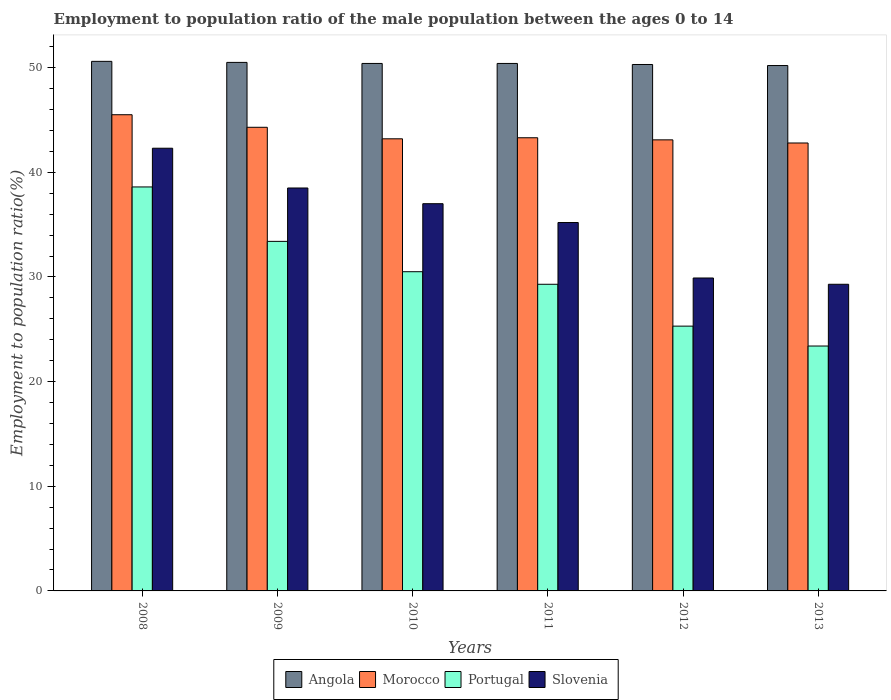How many groups of bars are there?
Ensure brevity in your answer.  6. Are the number of bars per tick equal to the number of legend labels?
Make the answer very short. Yes. How many bars are there on the 2nd tick from the left?
Offer a terse response. 4. What is the label of the 4th group of bars from the left?
Make the answer very short. 2011. What is the employment to population ratio in Angola in 2011?
Offer a terse response. 50.4. Across all years, what is the maximum employment to population ratio in Angola?
Provide a short and direct response. 50.6. Across all years, what is the minimum employment to population ratio in Portugal?
Give a very brief answer. 23.4. In which year was the employment to population ratio in Angola maximum?
Ensure brevity in your answer.  2008. What is the total employment to population ratio in Portugal in the graph?
Your response must be concise. 180.5. What is the difference between the employment to population ratio in Portugal in 2011 and the employment to population ratio in Morocco in 2013?
Your response must be concise. -13.5. What is the average employment to population ratio in Portugal per year?
Your answer should be compact. 30.08. In the year 2009, what is the difference between the employment to population ratio in Angola and employment to population ratio in Portugal?
Offer a terse response. 17.1. In how many years, is the employment to population ratio in Angola greater than 44 %?
Provide a succinct answer. 6. What is the ratio of the employment to population ratio in Portugal in 2009 to that in 2010?
Keep it short and to the point. 1.1. Is the employment to population ratio in Portugal in 2008 less than that in 2013?
Offer a terse response. No. What is the difference between the highest and the second highest employment to population ratio in Angola?
Offer a terse response. 0.1. What is the difference between the highest and the lowest employment to population ratio in Angola?
Keep it short and to the point. 0.4. What does the 4th bar from the left in 2009 represents?
Offer a terse response. Slovenia. What does the 3rd bar from the right in 2013 represents?
Make the answer very short. Morocco. Is it the case that in every year, the sum of the employment to population ratio in Slovenia and employment to population ratio in Morocco is greater than the employment to population ratio in Portugal?
Make the answer very short. Yes. How many bars are there?
Provide a short and direct response. 24. How many years are there in the graph?
Give a very brief answer. 6. What is the difference between two consecutive major ticks on the Y-axis?
Your answer should be very brief. 10. Where does the legend appear in the graph?
Provide a succinct answer. Bottom center. What is the title of the graph?
Your answer should be compact. Employment to population ratio of the male population between the ages 0 to 14. What is the label or title of the Y-axis?
Offer a very short reply. Employment to population ratio(%). What is the Employment to population ratio(%) of Angola in 2008?
Offer a very short reply. 50.6. What is the Employment to population ratio(%) in Morocco in 2008?
Keep it short and to the point. 45.5. What is the Employment to population ratio(%) of Portugal in 2008?
Provide a short and direct response. 38.6. What is the Employment to population ratio(%) in Slovenia in 2008?
Provide a succinct answer. 42.3. What is the Employment to population ratio(%) of Angola in 2009?
Provide a short and direct response. 50.5. What is the Employment to population ratio(%) of Morocco in 2009?
Ensure brevity in your answer.  44.3. What is the Employment to population ratio(%) of Portugal in 2009?
Keep it short and to the point. 33.4. What is the Employment to population ratio(%) of Slovenia in 2009?
Give a very brief answer. 38.5. What is the Employment to population ratio(%) of Angola in 2010?
Offer a terse response. 50.4. What is the Employment to population ratio(%) of Morocco in 2010?
Make the answer very short. 43.2. What is the Employment to population ratio(%) of Portugal in 2010?
Keep it short and to the point. 30.5. What is the Employment to population ratio(%) in Angola in 2011?
Offer a terse response. 50.4. What is the Employment to population ratio(%) of Morocco in 2011?
Give a very brief answer. 43.3. What is the Employment to population ratio(%) in Portugal in 2011?
Offer a very short reply. 29.3. What is the Employment to population ratio(%) in Slovenia in 2011?
Give a very brief answer. 35.2. What is the Employment to population ratio(%) of Angola in 2012?
Provide a short and direct response. 50.3. What is the Employment to population ratio(%) of Morocco in 2012?
Your answer should be very brief. 43.1. What is the Employment to population ratio(%) of Portugal in 2012?
Your answer should be very brief. 25.3. What is the Employment to population ratio(%) of Slovenia in 2012?
Provide a succinct answer. 29.9. What is the Employment to population ratio(%) of Angola in 2013?
Your answer should be compact. 50.2. What is the Employment to population ratio(%) of Morocco in 2013?
Provide a succinct answer. 42.8. What is the Employment to population ratio(%) in Portugal in 2013?
Ensure brevity in your answer.  23.4. What is the Employment to population ratio(%) of Slovenia in 2013?
Keep it short and to the point. 29.3. Across all years, what is the maximum Employment to population ratio(%) of Angola?
Make the answer very short. 50.6. Across all years, what is the maximum Employment to population ratio(%) of Morocco?
Provide a succinct answer. 45.5. Across all years, what is the maximum Employment to population ratio(%) in Portugal?
Provide a short and direct response. 38.6. Across all years, what is the maximum Employment to population ratio(%) of Slovenia?
Your answer should be very brief. 42.3. Across all years, what is the minimum Employment to population ratio(%) in Angola?
Make the answer very short. 50.2. Across all years, what is the minimum Employment to population ratio(%) in Morocco?
Offer a terse response. 42.8. Across all years, what is the minimum Employment to population ratio(%) of Portugal?
Give a very brief answer. 23.4. Across all years, what is the minimum Employment to population ratio(%) in Slovenia?
Ensure brevity in your answer.  29.3. What is the total Employment to population ratio(%) of Angola in the graph?
Your answer should be compact. 302.4. What is the total Employment to population ratio(%) of Morocco in the graph?
Give a very brief answer. 262.2. What is the total Employment to population ratio(%) of Portugal in the graph?
Provide a short and direct response. 180.5. What is the total Employment to population ratio(%) in Slovenia in the graph?
Provide a short and direct response. 212.2. What is the difference between the Employment to population ratio(%) in Morocco in 2008 and that in 2009?
Your answer should be very brief. 1.2. What is the difference between the Employment to population ratio(%) in Slovenia in 2008 and that in 2009?
Your answer should be compact. 3.8. What is the difference between the Employment to population ratio(%) in Slovenia in 2008 and that in 2010?
Make the answer very short. 5.3. What is the difference between the Employment to population ratio(%) in Angola in 2008 and that in 2011?
Your response must be concise. 0.2. What is the difference between the Employment to population ratio(%) in Portugal in 2008 and that in 2011?
Provide a succinct answer. 9.3. What is the difference between the Employment to population ratio(%) of Angola in 2008 and that in 2012?
Ensure brevity in your answer.  0.3. What is the difference between the Employment to population ratio(%) in Portugal in 2008 and that in 2012?
Your answer should be compact. 13.3. What is the difference between the Employment to population ratio(%) in Portugal in 2008 and that in 2013?
Provide a short and direct response. 15.2. What is the difference between the Employment to population ratio(%) of Morocco in 2009 and that in 2010?
Offer a very short reply. 1.1. What is the difference between the Employment to population ratio(%) in Angola in 2009 and that in 2011?
Your answer should be compact. 0.1. What is the difference between the Employment to population ratio(%) in Morocco in 2009 and that in 2011?
Provide a succinct answer. 1. What is the difference between the Employment to population ratio(%) of Portugal in 2009 and that in 2011?
Your response must be concise. 4.1. What is the difference between the Employment to population ratio(%) in Angola in 2009 and that in 2012?
Offer a very short reply. 0.2. What is the difference between the Employment to population ratio(%) of Morocco in 2009 and that in 2012?
Provide a succinct answer. 1.2. What is the difference between the Employment to population ratio(%) of Portugal in 2009 and that in 2012?
Your answer should be very brief. 8.1. What is the difference between the Employment to population ratio(%) of Slovenia in 2009 and that in 2012?
Provide a succinct answer. 8.6. What is the difference between the Employment to population ratio(%) in Portugal in 2010 and that in 2011?
Provide a succinct answer. 1.2. What is the difference between the Employment to population ratio(%) in Angola in 2010 and that in 2013?
Offer a terse response. 0.2. What is the difference between the Employment to population ratio(%) in Portugal in 2010 and that in 2013?
Keep it short and to the point. 7.1. What is the difference between the Employment to population ratio(%) in Slovenia in 2010 and that in 2013?
Offer a very short reply. 7.7. What is the difference between the Employment to population ratio(%) of Angola in 2011 and that in 2012?
Provide a short and direct response. 0.1. What is the difference between the Employment to population ratio(%) of Angola in 2011 and that in 2013?
Offer a very short reply. 0.2. What is the difference between the Employment to population ratio(%) in Slovenia in 2011 and that in 2013?
Your answer should be compact. 5.9. What is the difference between the Employment to population ratio(%) of Angola in 2012 and that in 2013?
Provide a short and direct response. 0.1. What is the difference between the Employment to population ratio(%) in Morocco in 2012 and that in 2013?
Make the answer very short. 0.3. What is the difference between the Employment to population ratio(%) of Slovenia in 2012 and that in 2013?
Offer a terse response. 0.6. What is the difference between the Employment to population ratio(%) in Angola in 2008 and the Employment to population ratio(%) in Morocco in 2009?
Offer a very short reply. 6.3. What is the difference between the Employment to population ratio(%) in Angola in 2008 and the Employment to population ratio(%) in Portugal in 2009?
Make the answer very short. 17.2. What is the difference between the Employment to population ratio(%) of Morocco in 2008 and the Employment to population ratio(%) of Portugal in 2009?
Keep it short and to the point. 12.1. What is the difference between the Employment to population ratio(%) in Morocco in 2008 and the Employment to population ratio(%) in Slovenia in 2009?
Offer a terse response. 7. What is the difference between the Employment to population ratio(%) in Portugal in 2008 and the Employment to population ratio(%) in Slovenia in 2009?
Ensure brevity in your answer.  0.1. What is the difference between the Employment to population ratio(%) in Angola in 2008 and the Employment to population ratio(%) in Morocco in 2010?
Your response must be concise. 7.4. What is the difference between the Employment to population ratio(%) in Angola in 2008 and the Employment to population ratio(%) in Portugal in 2010?
Your response must be concise. 20.1. What is the difference between the Employment to population ratio(%) of Morocco in 2008 and the Employment to population ratio(%) of Portugal in 2010?
Offer a terse response. 15. What is the difference between the Employment to population ratio(%) of Angola in 2008 and the Employment to population ratio(%) of Portugal in 2011?
Provide a succinct answer. 21.3. What is the difference between the Employment to population ratio(%) in Portugal in 2008 and the Employment to population ratio(%) in Slovenia in 2011?
Your response must be concise. 3.4. What is the difference between the Employment to population ratio(%) in Angola in 2008 and the Employment to population ratio(%) in Morocco in 2012?
Ensure brevity in your answer.  7.5. What is the difference between the Employment to population ratio(%) of Angola in 2008 and the Employment to population ratio(%) of Portugal in 2012?
Ensure brevity in your answer.  25.3. What is the difference between the Employment to population ratio(%) of Angola in 2008 and the Employment to population ratio(%) of Slovenia in 2012?
Give a very brief answer. 20.7. What is the difference between the Employment to population ratio(%) in Morocco in 2008 and the Employment to population ratio(%) in Portugal in 2012?
Your answer should be compact. 20.2. What is the difference between the Employment to population ratio(%) in Morocco in 2008 and the Employment to population ratio(%) in Slovenia in 2012?
Keep it short and to the point. 15.6. What is the difference between the Employment to population ratio(%) in Portugal in 2008 and the Employment to population ratio(%) in Slovenia in 2012?
Offer a very short reply. 8.7. What is the difference between the Employment to population ratio(%) in Angola in 2008 and the Employment to population ratio(%) in Morocco in 2013?
Your answer should be compact. 7.8. What is the difference between the Employment to population ratio(%) in Angola in 2008 and the Employment to population ratio(%) in Portugal in 2013?
Offer a terse response. 27.2. What is the difference between the Employment to population ratio(%) of Angola in 2008 and the Employment to population ratio(%) of Slovenia in 2013?
Ensure brevity in your answer.  21.3. What is the difference between the Employment to population ratio(%) in Morocco in 2008 and the Employment to population ratio(%) in Portugal in 2013?
Make the answer very short. 22.1. What is the difference between the Employment to population ratio(%) of Morocco in 2008 and the Employment to population ratio(%) of Slovenia in 2013?
Your response must be concise. 16.2. What is the difference between the Employment to population ratio(%) of Portugal in 2008 and the Employment to population ratio(%) of Slovenia in 2013?
Offer a very short reply. 9.3. What is the difference between the Employment to population ratio(%) of Angola in 2009 and the Employment to population ratio(%) of Portugal in 2010?
Offer a very short reply. 20. What is the difference between the Employment to population ratio(%) in Angola in 2009 and the Employment to population ratio(%) in Slovenia in 2010?
Provide a short and direct response. 13.5. What is the difference between the Employment to population ratio(%) of Morocco in 2009 and the Employment to population ratio(%) of Portugal in 2010?
Offer a very short reply. 13.8. What is the difference between the Employment to population ratio(%) in Angola in 2009 and the Employment to population ratio(%) in Morocco in 2011?
Offer a terse response. 7.2. What is the difference between the Employment to population ratio(%) of Angola in 2009 and the Employment to population ratio(%) of Portugal in 2011?
Keep it short and to the point. 21.2. What is the difference between the Employment to population ratio(%) in Angola in 2009 and the Employment to population ratio(%) in Slovenia in 2011?
Make the answer very short. 15.3. What is the difference between the Employment to population ratio(%) in Morocco in 2009 and the Employment to population ratio(%) in Portugal in 2011?
Your answer should be compact. 15. What is the difference between the Employment to population ratio(%) in Morocco in 2009 and the Employment to population ratio(%) in Slovenia in 2011?
Offer a very short reply. 9.1. What is the difference between the Employment to population ratio(%) of Angola in 2009 and the Employment to population ratio(%) of Morocco in 2012?
Ensure brevity in your answer.  7.4. What is the difference between the Employment to population ratio(%) in Angola in 2009 and the Employment to population ratio(%) in Portugal in 2012?
Provide a short and direct response. 25.2. What is the difference between the Employment to population ratio(%) in Angola in 2009 and the Employment to population ratio(%) in Slovenia in 2012?
Offer a terse response. 20.6. What is the difference between the Employment to population ratio(%) in Morocco in 2009 and the Employment to population ratio(%) in Slovenia in 2012?
Your answer should be very brief. 14.4. What is the difference between the Employment to population ratio(%) in Portugal in 2009 and the Employment to population ratio(%) in Slovenia in 2012?
Offer a very short reply. 3.5. What is the difference between the Employment to population ratio(%) in Angola in 2009 and the Employment to population ratio(%) in Morocco in 2013?
Give a very brief answer. 7.7. What is the difference between the Employment to population ratio(%) in Angola in 2009 and the Employment to population ratio(%) in Portugal in 2013?
Your answer should be very brief. 27.1. What is the difference between the Employment to population ratio(%) in Angola in 2009 and the Employment to population ratio(%) in Slovenia in 2013?
Your response must be concise. 21.2. What is the difference between the Employment to population ratio(%) in Morocco in 2009 and the Employment to population ratio(%) in Portugal in 2013?
Make the answer very short. 20.9. What is the difference between the Employment to population ratio(%) of Angola in 2010 and the Employment to population ratio(%) of Portugal in 2011?
Make the answer very short. 21.1. What is the difference between the Employment to population ratio(%) of Angola in 2010 and the Employment to population ratio(%) of Slovenia in 2011?
Ensure brevity in your answer.  15.2. What is the difference between the Employment to population ratio(%) of Morocco in 2010 and the Employment to population ratio(%) of Portugal in 2011?
Provide a short and direct response. 13.9. What is the difference between the Employment to population ratio(%) of Angola in 2010 and the Employment to population ratio(%) of Portugal in 2012?
Your response must be concise. 25.1. What is the difference between the Employment to population ratio(%) in Morocco in 2010 and the Employment to population ratio(%) in Portugal in 2012?
Provide a succinct answer. 17.9. What is the difference between the Employment to population ratio(%) of Portugal in 2010 and the Employment to population ratio(%) of Slovenia in 2012?
Offer a very short reply. 0.6. What is the difference between the Employment to population ratio(%) in Angola in 2010 and the Employment to population ratio(%) in Morocco in 2013?
Provide a succinct answer. 7.6. What is the difference between the Employment to population ratio(%) of Angola in 2010 and the Employment to population ratio(%) of Slovenia in 2013?
Your answer should be very brief. 21.1. What is the difference between the Employment to population ratio(%) of Morocco in 2010 and the Employment to population ratio(%) of Portugal in 2013?
Provide a succinct answer. 19.8. What is the difference between the Employment to population ratio(%) in Angola in 2011 and the Employment to population ratio(%) in Morocco in 2012?
Offer a very short reply. 7.3. What is the difference between the Employment to population ratio(%) in Angola in 2011 and the Employment to population ratio(%) in Portugal in 2012?
Provide a succinct answer. 25.1. What is the difference between the Employment to population ratio(%) in Angola in 2011 and the Employment to population ratio(%) in Slovenia in 2013?
Your answer should be compact. 21.1. What is the difference between the Employment to population ratio(%) of Morocco in 2011 and the Employment to population ratio(%) of Portugal in 2013?
Offer a very short reply. 19.9. What is the difference between the Employment to population ratio(%) of Morocco in 2011 and the Employment to population ratio(%) of Slovenia in 2013?
Your answer should be very brief. 14. What is the difference between the Employment to population ratio(%) in Angola in 2012 and the Employment to population ratio(%) in Portugal in 2013?
Offer a terse response. 26.9. What is the difference between the Employment to population ratio(%) in Morocco in 2012 and the Employment to population ratio(%) in Slovenia in 2013?
Give a very brief answer. 13.8. What is the average Employment to population ratio(%) in Angola per year?
Provide a succinct answer. 50.4. What is the average Employment to population ratio(%) of Morocco per year?
Your answer should be very brief. 43.7. What is the average Employment to population ratio(%) in Portugal per year?
Make the answer very short. 30.08. What is the average Employment to population ratio(%) of Slovenia per year?
Give a very brief answer. 35.37. In the year 2008, what is the difference between the Employment to population ratio(%) of Angola and Employment to population ratio(%) of Portugal?
Ensure brevity in your answer.  12. In the year 2008, what is the difference between the Employment to population ratio(%) in Morocco and Employment to population ratio(%) in Portugal?
Offer a terse response. 6.9. In the year 2009, what is the difference between the Employment to population ratio(%) of Angola and Employment to population ratio(%) of Morocco?
Provide a succinct answer. 6.2. In the year 2009, what is the difference between the Employment to population ratio(%) of Angola and Employment to population ratio(%) of Portugal?
Ensure brevity in your answer.  17.1. In the year 2009, what is the difference between the Employment to population ratio(%) of Morocco and Employment to population ratio(%) of Slovenia?
Provide a short and direct response. 5.8. In the year 2009, what is the difference between the Employment to population ratio(%) in Portugal and Employment to population ratio(%) in Slovenia?
Ensure brevity in your answer.  -5.1. In the year 2010, what is the difference between the Employment to population ratio(%) in Angola and Employment to population ratio(%) in Morocco?
Provide a short and direct response. 7.2. In the year 2010, what is the difference between the Employment to population ratio(%) in Portugal and Employment to population ratio(%) in Slovenia?
Your answer should be very brief. -6.5. In the year 2011, what is the difference between the Employment to population ratio(%) in Angola and Employment to population ratio(%) in Portugal?
Your answer should be compact. 21.1. In the year 2011, what is the difference between the Employment to population ratio(%) of Morocco and Employment to population ratio(%) of Portugal?
Your answer should be very brief. 14. In the year 2011, what is the difference between the Employment to population ratio(%) of Morocco and Employment to population ratio(%) of Slovenia?
Your answer should be compact. 8.1. In the year 2012, what is the difference between the Employment to population ratio(%) of Angola and Employment to population ratio(%) of Morocco?
Your answer should be very brief. 7.2. In the year 2012, what is the difference between the Employment to population ratio(%) in Angola and Employment to population ratio(%) in Slovenia?
Offer a terse response. 20.4. In the year 2012, what is the difference between the Employment to population ratio(%) of Morocco and Employment to population ratio(%) of Portugal?
Give a very brief answer. 17.8. In the year 2012, what is the difference between the Employment to population ratio(%) in Morocco and Employment to population ratio(%) in Slovenia?
Your answer should be compact. 13.2. In the year 2012, what is the difference between the Employment to population ratio(%) of Portugal and Employment to population ratio(%) of Slovenia?
Provide a succinct answer. -4.6. In the year 2013, what is the difference between the Employment to population ratio(%) of Angola and Employment to population ratio(%) of Morocco?
Offer a terse response. 7.4. In the year 2013, what is the difference between the Employment to population ratio(%) in Angola and Employment to population ratio(%) in Portugal?
Your response must be concise. 26.8. In the year 2013, what is the difference between the Employment to population ratio(%) in Angola and Employment to population ratio(%) in Slovenia?
Ensure brevity in your answer.  20.9. In the year 2013, what is the difference between the Employment to population ratio(%) of Morocco and Employment to population ratio(%) of Portugal?
Give a very brief answer. 19.4. What is the ratio of the Employment to population ratio(%) in Morocco in 2008 to that in 2009?
Offer a terse response. 1.03. What is the ratio of the Employment to population ratio(%) of Portugal in 2008 to that in 2009?
Give a very brief answer. 1.16. What is the ratio of the Employment to population ratio(%) of Slovenia in 2008 to that in 2009?
Your response must be concise. 1.1. What is the ratio of the Employment to population ratio(%) of Morocco in 2008 to that in 2010?
Your answer should be compact. 1.05. What is the ratio of the Employment to population ratio(%) in Portugal in 2008 to that in 2010?
Ensure brevity in your answer.  1.27. What is the ratio of the Employment to population ratio(%) of Slovenia in 2008 to that in 2010?
Ensure brevity in your answer.  1.14. What is the ratio of the Employment to population ratio(%) in Morocco in 2008 to that in 2011?
Provide a short and direct response. 1.05. What is the ratio of the Employment to population ratio(%) of Portugal in 2008 to that in 2011?
Your answer should be compact. 1.32. What is the ratio of the Employment to population ratio(%) of Slovenia in 2008 to that in 2011?
Your answer should be compact. 1.2. What is the ratio of the Employment to population ratio(%) of Morocco in 2008 to that in 2012?
Your response must be concise. 1.06. What is the ratio of the Employment to population ratio(%) in Portugal in 2008 to that in 2012?
Give a very brief answer. 1.53. What is the ratio of the Employment to population ratio(%) of Slovenia in 2008 to that in 2012?
Keep it short and to the point. 1.41. What is the ratio of the Employment to population ratio(%) in Morocco in 2008 to that in 2013?
Offer a very short reply. 1.06. What is the ratio of the Employment to population ratio(%) in Portugal in 2008 to that in 2013?
Give a very brief answer. 1.65. What is the ratio of the Employment to population ratio(%) of Slovenia in 2008 to that in 2013?
Your response must be concise. 1.44. What is the ratio of the Employment to population ratio(%) in Morocco in 2009 to that in 2010?
Your answer should be very brief. 1.03. What is the ratio of the Employment to population ratio(%) of Portugal in 2009 to that in 2010?
Give a very brief answer. 1.1. What is the ratio of the Employment to population ratio(%) in Slovenia in 2009 to that in 2010?
Provide a short and direct response. 1.04. What is the ratio of the Employment to population ratio(%) of Angola in 2009 to that in 2011?
Your answer should be very brief. 1. What is the ratio of the Employment to population ratio(%) in Morocco in 2009 to that in 2011?
Make the answer very short. 1.02. What is the ratio of the Employment to population ratio(%) in Portugal in 2009 to that in 2011?
Your response must be concise. 1.14. What is the ratio of the Employment to population ratio(%) of Slovenia in 2009 to that in 2011?
Provide a short and direct response. 1.09. What is the ratio of the Employment to population ratio(%) of Morocco in 2009 to that in 2012?
Your answer should be very brief. 1.03. What is the ratio of the Employment to population ratio(%) of Portugal in 2009 to that in 2012?
Your answer should be compact. 1.32. What is the ratio of the Employment to population ratio(%) of Slovenia in 2009 to that in 2012?
Make the answer very short. 1.29. What is the ratio of the Employment to population ratio(%) in Angola in 2009 to that in 2013?
Keep it short and to the point. 1.01. What is the ratio of the Employment to population ratio(%) of Morocco in 2009 to that in 2013?
Give a very brief answer. 1.03. What is the ratio of the Employment to population ratio(%) in Portugal in 2009 to that in 2013?
Keep it short and to the point. 1.43. What is the ratio of the Employment to population ratio(%) of Slovenia in 2009 to that in 2013?
Your answer should be very brief. 1.31. What is the ratio of the Employment to population ratio(%) in Morocco in 2010 to that in 2011?
Offer a terse response. 1. What is the ratio of the Employment to population ratio(%) of Portugal in 2010 to that in 2011?
Provide a succinct answer. 1.04. What is the ratio of the Employment to population ratio(%) of Slovenia in 2010 to that in 2011?
Offer a very short reply. 1.05. What is the ratio of the Employment to population ratio(%) of Morocco in 2010 to that in 2012?
Offer a very short reply. 1. What is the ratio of the Employment to population ratio(%) in Portugal in 2010 to that in 2012?
Your response must be concise. 1.21. What is the ratio of the Employment to population ratio(%) in Slovenia in 2010 to that in 2012?
Offer a very short reply. 1.24. What is the ratio of the Employment to population ratio(%) in Morocco in 2010 to that in 2013?
Offer a terse response. 1.01. What is the ratio of the Employment to population ratio(%) in Portugal in 2010 to that in 2013?
Offer a terse response. 1.3. What is the ratio of the Employment to population ratio(%) of Slovenia in 2010 to that in 2013?
Your response must be concise. 1.26. What is the ratio of the Employment to population ratio(%) in Portugal in 2011 to that in 2012?
Give a very brief answer. 1.16. What is the ratio of the Employment to population ratio(%) of Slovenia in 2011 to that in 2012?
Provide a short and direct response. 1.18. What is the ratio of the Employment to population ratio(%) in Morocco in 2011 to that in 2013?
Ensure brevity in your answer.  1.01. What is the ratio of the Employment to population ratio(%) of Portugal in 2011 to that in 2013?
Make the answer very short. 1.25. What is the ratio of the Employment to population ratio(%) of Slovenia in 2011 to that in 2013?
Give a very brief answer. 1.2. What is the ratio of the Employment to population ratio(%) of Angola in 2012 to that in 2013?
Provide a succinct answer. 1. What is the ratio of the Employment to population ratio(%) of Portugal in 2012 to that in 2013?
Offer a terse response. 1.08. What is the ratio of the Employment to population ratio(%) of Slovenia in 2012 to that in 2013?
Your answer should be very brief. 1.02. What is the difference between the highest and the second highest Employment to population ratio(%) in Morocco?
Provide a short and direct response. 1.2. What is the difference between the highest and the second highest Employment to population ratio(%) in Portugal?
Give a very brief answer. 5.2. What is the difference between the highest and the second highest Employment to population ratio(%) of Slovenia?
Make the answer very short. 3.8. 